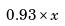Convert formula to latex. <formula><loc_0><loc_0><loc_500><loc_500>0 . 9 3 \times x</formula> 